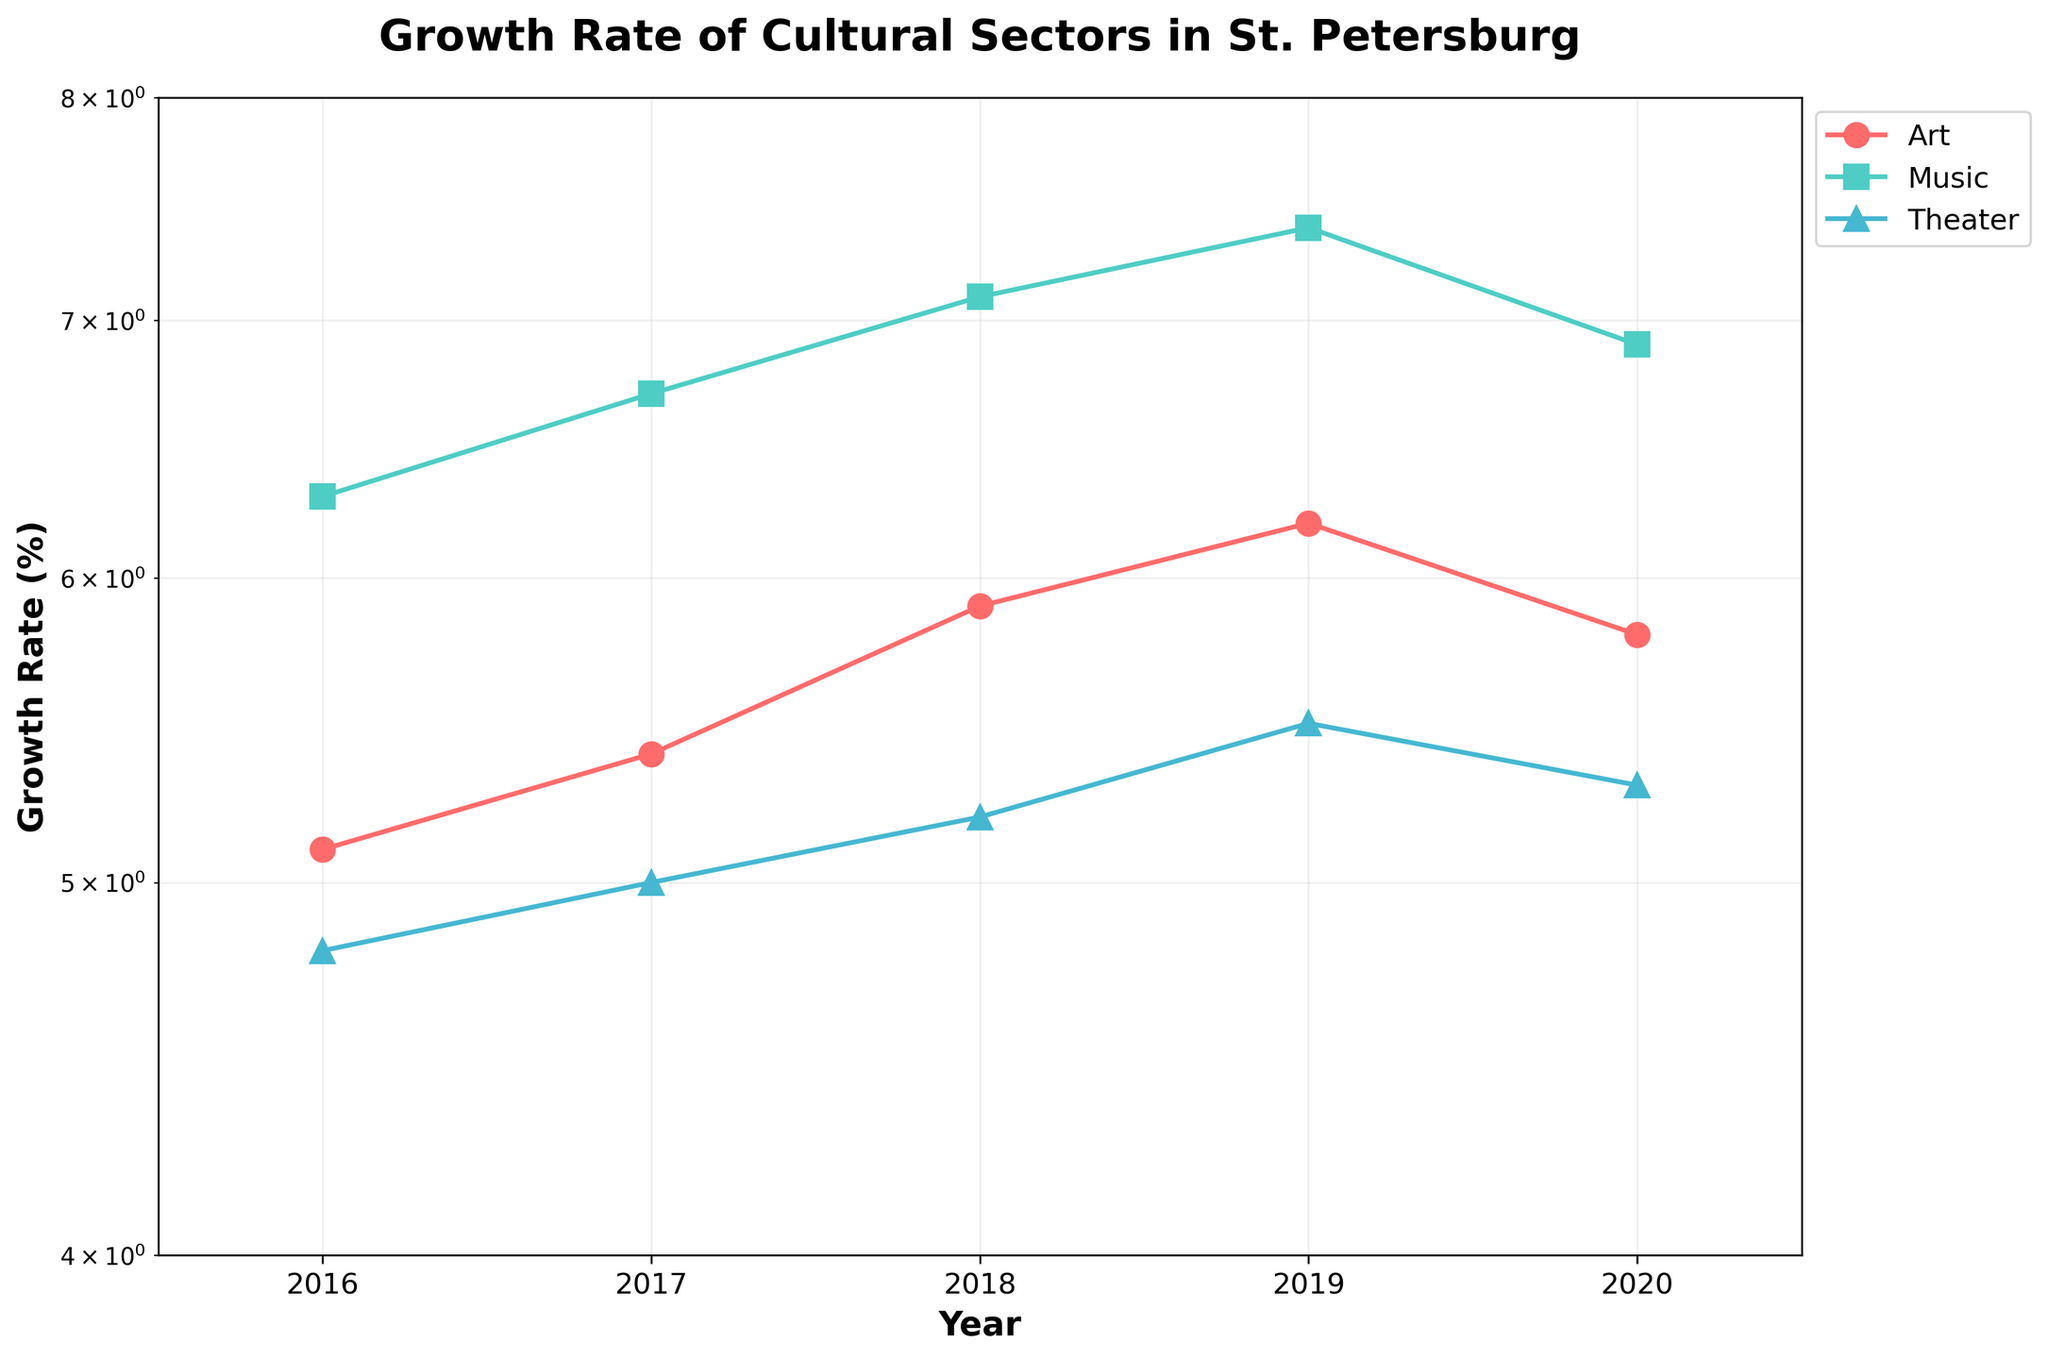What's the title of the figure? The figure's title is shown at the top. The title is “Growth Rate of Cultural Sectors in St. Petersburg”.
Answer: Growth Rate of Cultural Sectors in St. Petersburg What does the y-axis represent? The y-axis is labeled “Growth Rate (%)” and represents the growth rate percentage of different sectors.
Answer: Growth Rate (%) What is the range of the y-axis? The y-axis grid lines indicate that the range is from 4% to 8%. The label and log scale imply these values.
Answer: 4% to 8% Which sector had the highest growth rate in 2019? By locating 2019 on the x-axis and viewing the y-values above it, the blue line (music) is highest.
Answer: Music What's the general trend in the growth rate of the art sector from 2016 to 2020? By observing the red line marked “Art”, we see it generally increases from 2016 to 2019 and slightly decreases in 2020.
Answer: Increasing, with a slight decrease in 2020 Which sector experienced a decline in growth rate from 2019 to 2020? Observing the plots from 2019 to 2020, both the "Art" and "Music" sectors show a decline.
Answer: Art and Music How many sectors are displayed in the plot? Each line and legend entry represents a sector, with three lines and three legend entries in total.
Answer: Three sectors What is the average growth rate for the theater sector from 2018 to 2020? The theater growth rates for 2018, 2019, and 2020 are 5.2%, 5.5%, and 5.3%. The average is calculated as (5.2 + 5.5 + 5.3) / 3 = 5.33%.
Answer: 5.33% By how much did the growth rate of music change from 2016 to 2019? The growth rate of music in 2016 is 6.3% and in 2019 it is 7.4%. The change is 7.4% - 6.3% = 1.1%.
Answer: 1.1% What is the largest growth rate observed for any sector in any year? By inspecting all the data points, the highest point is the music sector in 2019 at 7.4%.
Answer: 7.4% 